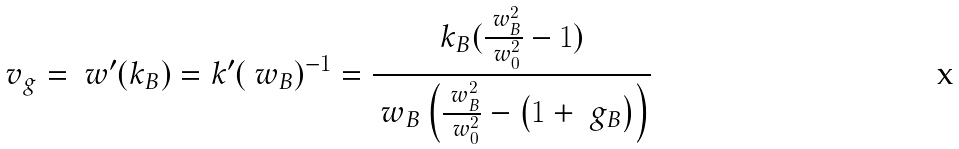<formula> <loc_0><loc_0><loc_500><loc_500>v _ { g } = \ w ^ { \prime } ( k _ { B } ) = k ^ { \prime } ( \ w _ { B } ) ^ { - 1 } = \frac { k _ { B } ( \frac { \ w _ { B } ^ { 2 } } { \ w _ { 0 } ^ { 2 } } - 1 ) } { \ w _ { B } \left ( \frac { \ w _ { B } ^ { 2 } } { \ w _ { 0 } ^ { 2 } } - \left ( 1 + \ g _ { B } \right ) \right ) }</formula> 